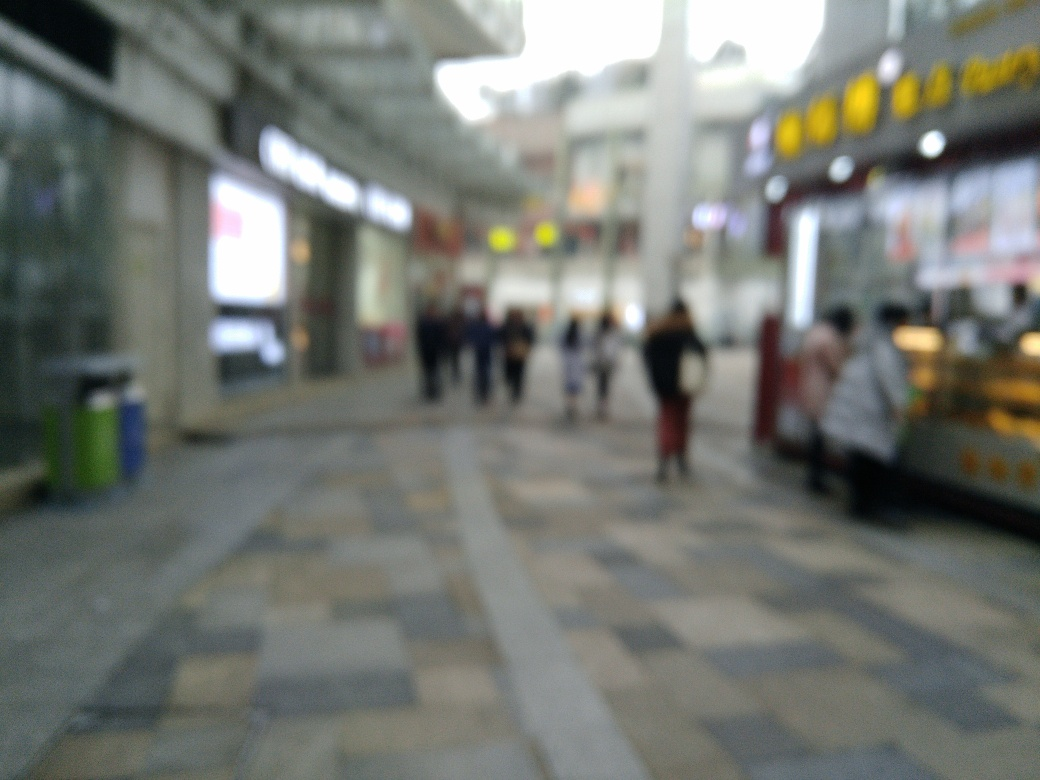Is there anything in this photo that indicates the season or weather? Not conclusively; however, people seem to be dressed in light clothing which could suggest a warmer season, although the image blur makes it difficult to make out the specific weather conditions. 